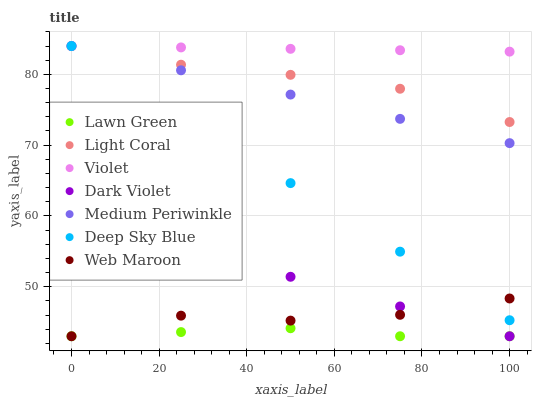Does Lawn Green have the minimum area under the curve?
Answer yes or no. Yes. Does Violet have the maximum area under the curve?
Answer yes or no. Yes. Does Web Maroon have the minimum area under the curve?
Answer yes or no. No. Does Web Maroon have the maximum area under the curve?
Answer yes or no. No. Is Medium Periwinkle the smoothest?
Answer yes or no. Yes. Is Web Maroon the roughest?
Answer yes or no. Yes. Is Web Maroon the smoothest?
Answer yes or no. No. Is Medium Periwinkle the roughest?
Answer yes or no. No. Does Lawn Green have the lowest value?
Answer yes or no. Yes. Does Medium Periwinkle have the lowest value?
Answer yes or no. No. Does Violet have the highest value?
Answer yes or no. Yes. Does Web Maroon have the highest value?
Answer yes or no. No. Is Lawn Green less than Light Coral?
Answer yes or no. Yes. Is Deep Sky Blue greater than Lawn Green?
Answer yes or no. Yes. Does Deep Sky Blue intersect Medium Periwinkle?
Answer yes or no. Yes. Is Deep Sky Blue less than Medium Periwinkle?
Answer yes or no. No. Is Deep Sky Blue greater than Medium Periwinkle?
Answer yes or no. No. Does Lawn Green intersect Light Coral?
Answer yes or no. No. 